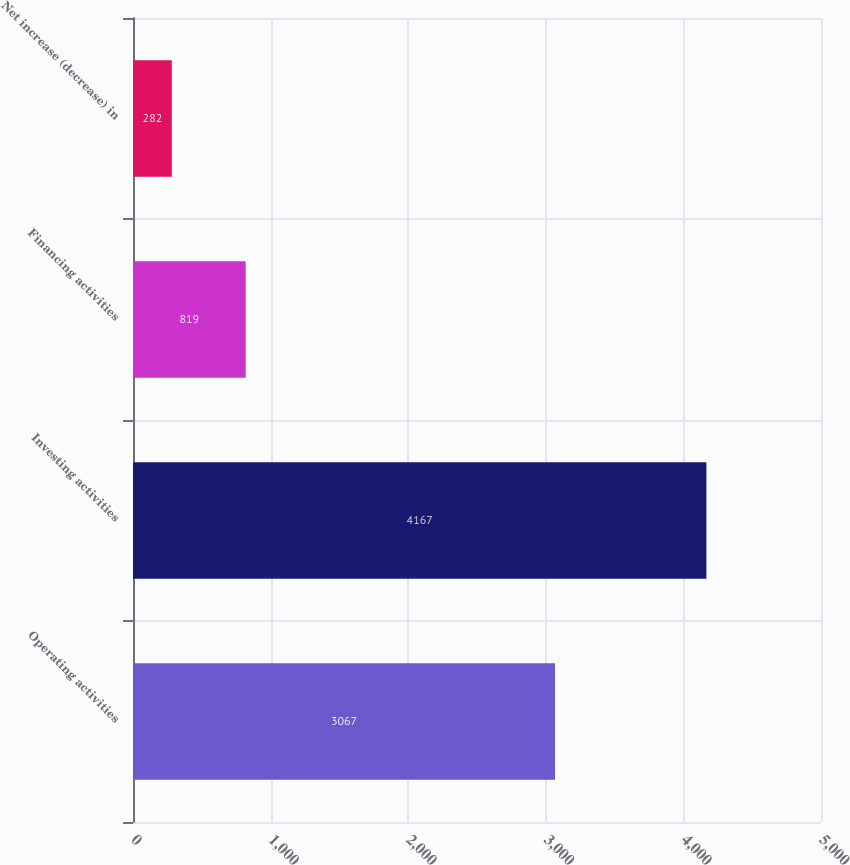Convert chart. <chart><loc_0><loc_0><loc_500><loc_500><bar_chart><fcel>Operating activities<fcel>Investing activities<fcel>Financing activities<fcel>Net increase (decrease) in<nl><fcel>3067<fcel>4167<fcel>819<fcel>282<nl></chart> 